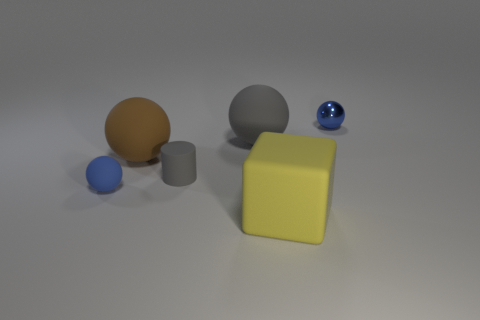There is a big gray thing that is made of the same material as the small cylinder; what shape is it?
Your response must be concise. Sphere. What material is the blue ball that is on the right side of the blue ball that is in front of the object that is to the right of the big rubber cube?
Make the answer very short. Metal. How many things are big objects behind the big brown thing or blue shiny things?
Your answer should be compact. 2. How many other things are the same shape as the metal object?
Offer a terse response. 3. Are there more small gray cylinders that are left of the small gray matte thing than large matte things?
Keep it short and to the point. No. There is a brown thing that is the same shape as the small blue metal object; what is its size?
Your answer should be very brief. Large. The tiny blue rubber object has what shape?
Your answer should be very brief. Sphere. What shape is the brown thing that is the same size as the yellow cube?
Your response must be concise. Sphere. Is there anything else that is the same color as the rubber cube?
Offer a very short reply. No. The brown sphere that is the same material as the large yellow thing is what size?
Provide a succinct answer. Large. 